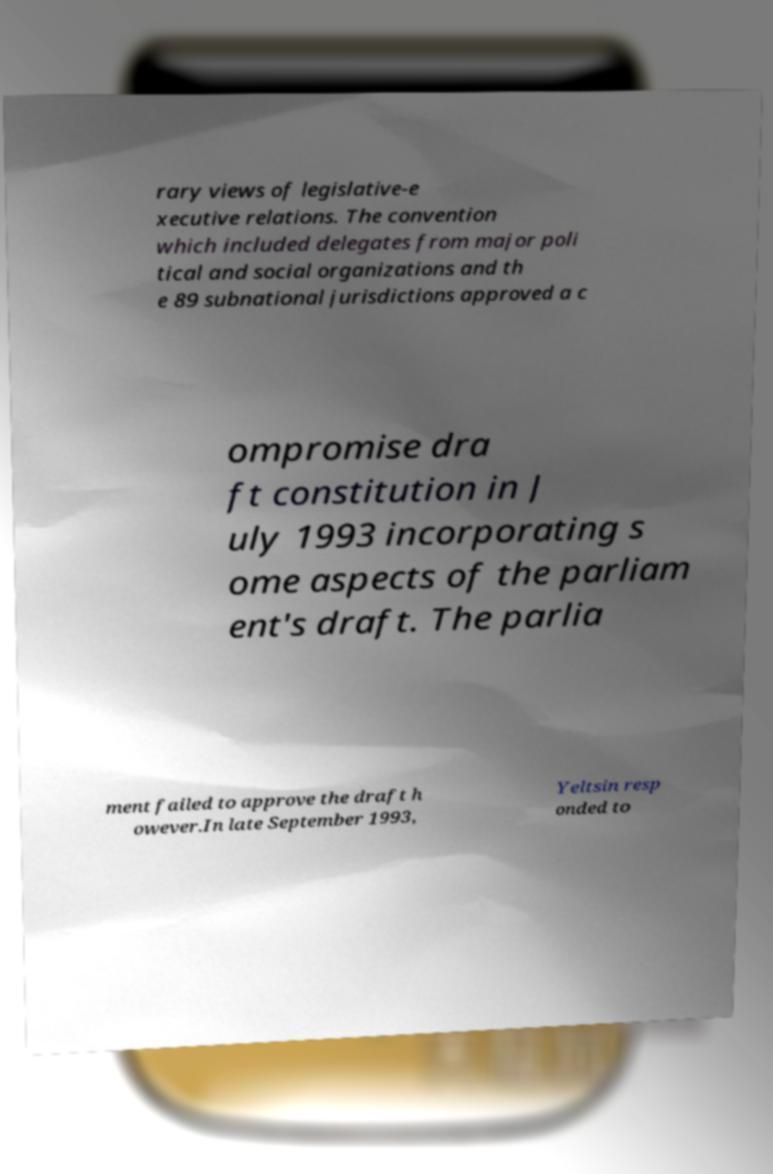There's text embedded in this image that I need extracted. Can you transcribe it verbatim? rary views of legislative-e xecutive relations. The convention which included delegates from major poli tical and social organizations and th e 89 subnational jurisdictions approved a c ompromise dra ft constitution in J uly 1993 incorporating s ome aspects of the parliam ent's draft. The parlia ment failed to approve the draft h owever.In late September 1993, Yeltsin resp onded to 